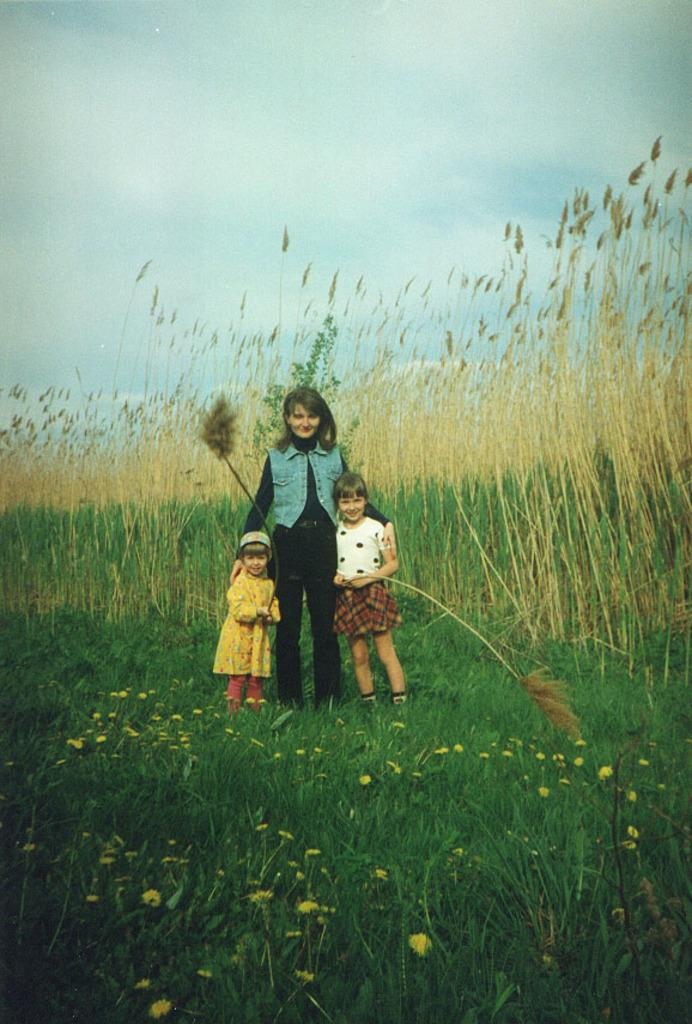How many kids are present in the image? There are three kids standing in the image. What is at the bottom of the image? There is grass at the bottom of the image. What can be seen in the background of the image? There are plants in the background of the image. What is visible at the top of the image? The sky is visible at the top of the image. Where is the can located in the image? There is no can present in the image. What type of locket is the kid wearing in the image? There is no locket visible on any of the kids in the image. 